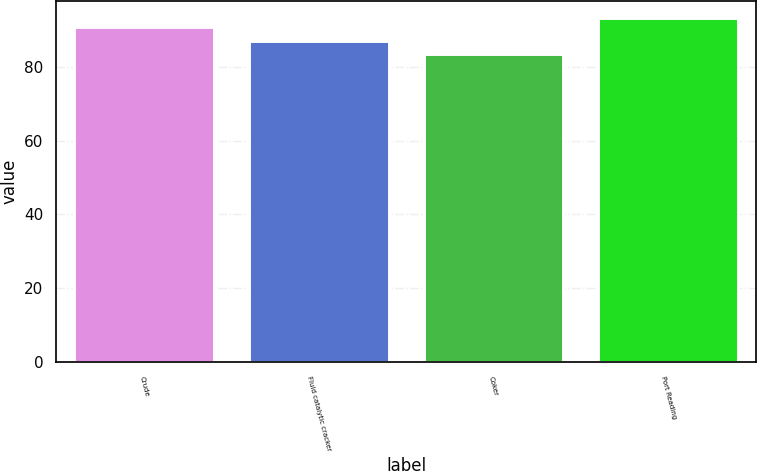Convert chart. <chart><loc_0><loc_0><loc_500><loc_500><bar_chart><fcel>Crude<fcel>Fluid catalytic cracker<fcel>Coker<fcel>Port Reading<nl><fcel>90.8<fcel>87.1<fcel>83.4<fcel>93.2<nl></chart> 